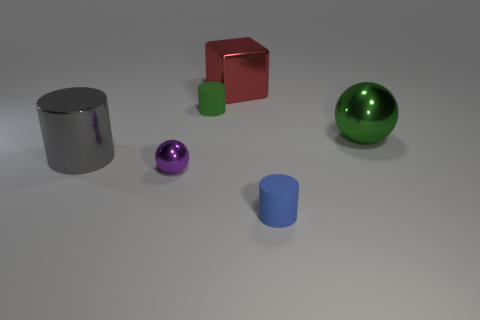What material is the small sphere that is to the left of the small rubber cylinder that is in front of the green rubber thing? The small sphere to the left of the small rubber cylinder, positioned in front of the green rubber item, appears to be made from a shiny, metallic material, suggesting it could be metal, possibly steel or aluminum, given its reflective surface and silver color. 